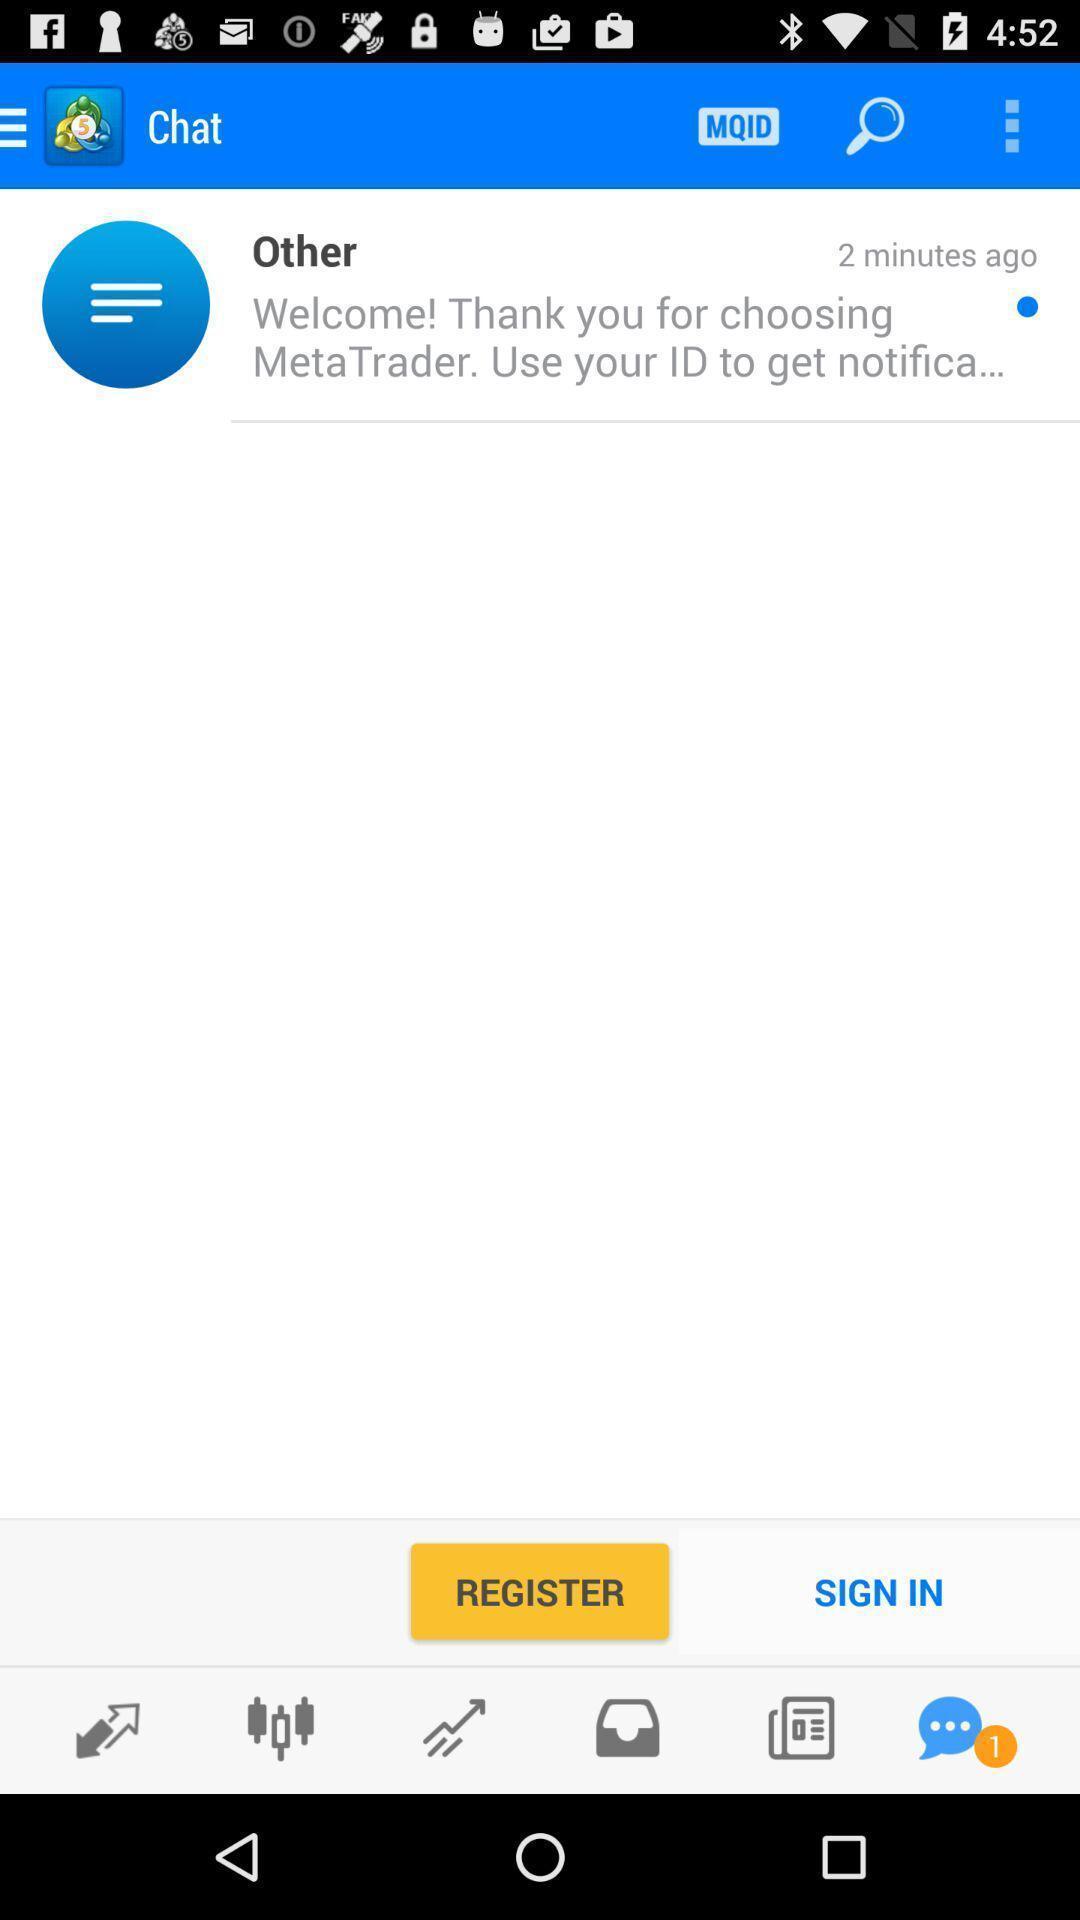Give me a narrative description of this picture. Sign in page for a social app. 